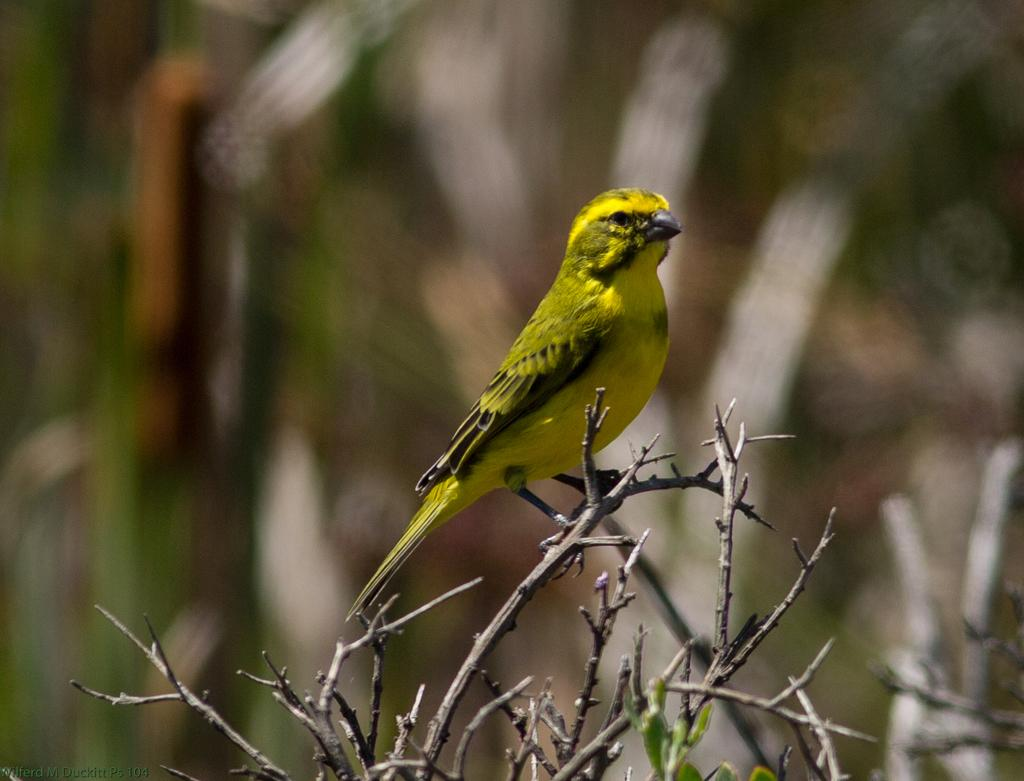What is the person in the image holding? The person is holding a surfboard. Where is the person located in the image? The person is located near a beach. What can be seen in the background of the image? There is a beach in the background of the image. How many dimes can be seen on the person's knee in the image? There are no dimes visible on the person's knee in the image. 